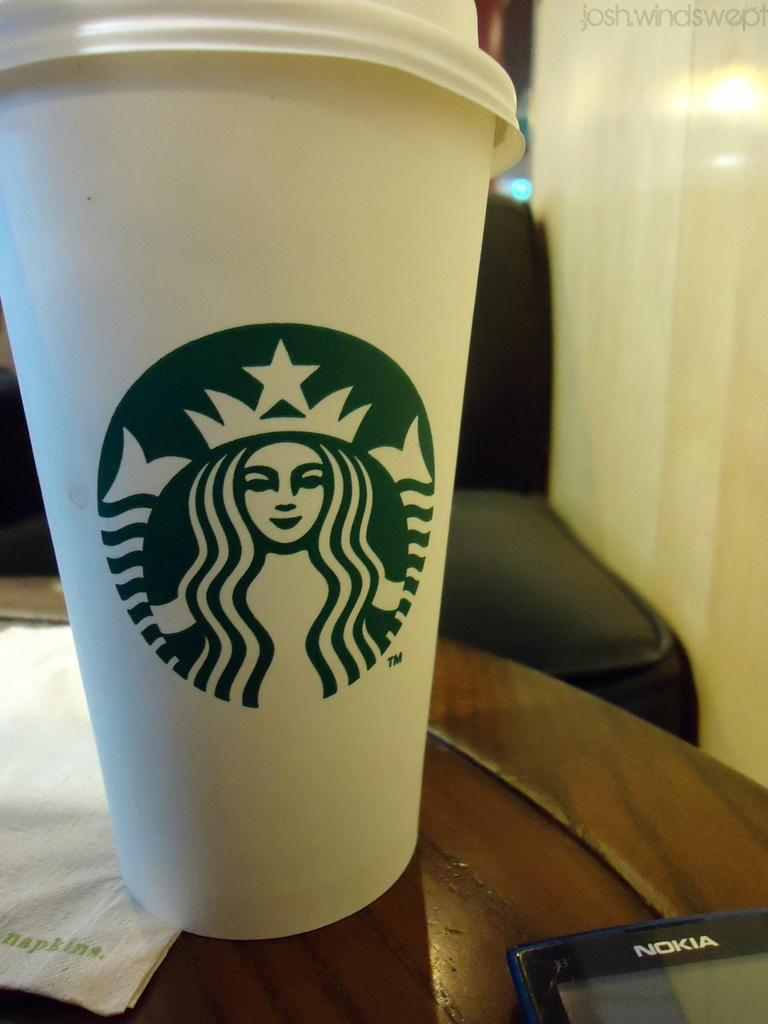What object is placed on the table in the image? There is a cup on the table. What other object can be seen on the table? There is a phone on the table. Where is the notebook located in the image? There is no notebook present in the image. What type of answer can be found in the image? The image does not contain any questions or answers; it only shows a cup and a phone on a table. 